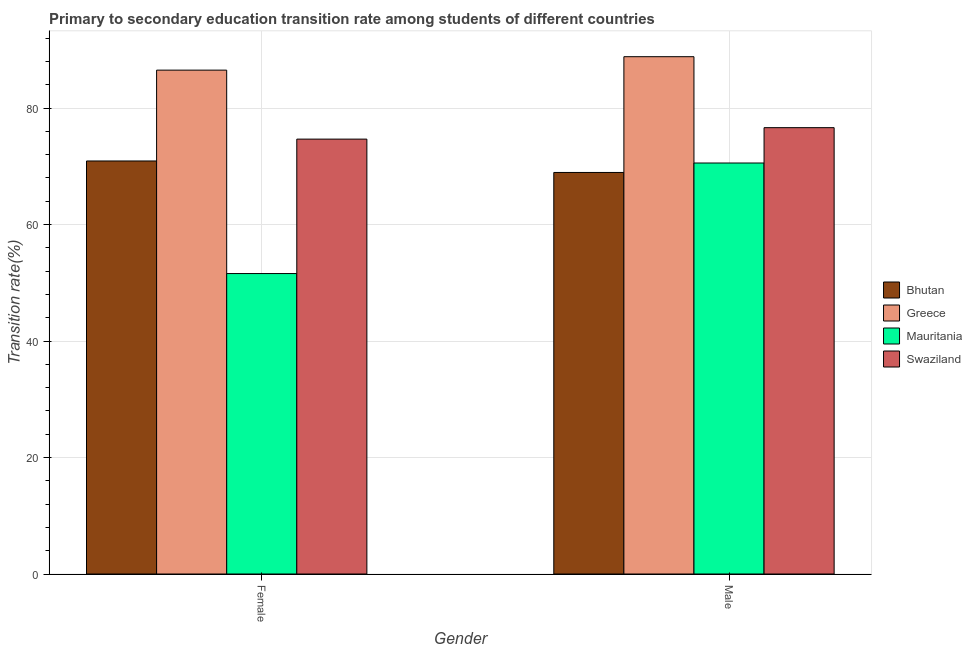How many different coloured bars are there?
Offer a terse response. 4. Are the number of bars per tick equal to the number of legend labels?
Your answer should be compact. Yes. How many bars are there on the 2nd tick from the right?
Provide a short and direct response. 4. What is the label of the 2nd group of bars from the left?
Keep it short and to the point. Male. What is the transition rate among female students in Mauritania?
Your response must be concise. 51.59. Across all countries, what is the maximum transition rate among female students?
Ensure brevity in your answer.  86.52. Across all countries, what is the minimum transition rate among male students?
Your answer should be very brief. 68.95. In which country was the transition rate among male students maximum?
Provide a succinct answer. Greece. In which country was the transition rate among female students minimum?
Your answer should be very brief. Mauritania. What is the total transition rate among female students in the graph?
Keep it short and to the point. 283.7. What is the difference between the transition rate among female students in Bhutan and that in Mauritania?
Keep it short and to the point. 19.33. What is the difference between the transition rate among male students in Greece and the transition rate among female students in Mauritania?
Provide a short and direct response. 37.24. What is the average transition rate among male students per country?
Your answer should be compact. 76.25. What is the difference between the transition rate among male students and transition rate among female students in Mauritania?
Your response must be concise. 18.98. In how many countries, is the transition rate among female students greater than 20 %?
Provide a short and direct response. 4. What is the ratio of the transition rate among male students in Bhutan to that in Mauritania?
Provide a succinct answer. 0.98. Is the transition rate among male students in Mauritania less than that in Swaziland?
Provide a succinct answer. Yes. What does the 1st bar from the left in Female represents?
Provide a short and direct response. Bhutan. What does the 2nd bar from the right in Male represents?
Make the answer very short. Mauritania. How many countries are there in the graph?
Offer a very short reply. 4. Where does the legend appear in the graph?
Ensure brevity in your answer.  Center right. How many legend labels are there?
Give a very brief answer. 4. What is the title of the graph?
Make the answer very short. Primary to secondary education transition rate among students of different countries. What is the label or title of the Y-axis?
Your answer should be very brief. Transition rate(%). What is the Transition rate(%) in Bhutan in Female?
Keep it short and to the point. 70.92. What is the Transition rate(%) in Greece in Female?
Ensure brevity in your answer.  86.52. What is the Transition rate(%) of Mauritania in Female?
Provide a succinct answer. 51.59. What is the Transition rate(%) of Swaziland in Female?
Make the answer very short. 74.67. What is the Transition rate(%) of Bhutan in Male?
Your answer should be compact. 68.95. What is the Transition rate(%) of Greece in Male?
Offer a very short reply. 88.83. What is the Transition rate(%) of Mauritania in Male?
Make the answer very short. 70.57. What is the Transition rate(%) in Swaziland in Male?
Provide a succinct answer. 76.64. Across all Gender, what is the maximum Transition rate(%) in Bhutan?
Provide a short and direct response. 70.92. Across all Gender, what is the maximum Transition rate(%) in Greece?
Ensure brevity in your answer.  88.83. Across all Gender, what is the maximum Transition rate(%) of Mauritania?
Offer a terse response. 70.57. Across all Gender, what is the maximum Transition rate(%) in Swaziland?
Provide a succinct answer. 76.64. Across all Gender, what is the minimum Transition rate(%) in Bhutan?
Offer a very short reply. 68.95. Across all Gender, what is the minimum Transition rate(%) in Greece?
Your response must be concise. 86.52. Across all Gender, what is the minimum Transition rate(%) of Mauritania?
Your answer should be very brief. 51.59. Across all Gender, what is the minimum Transition rate(%) of Swaziland?
Provide a short and direct response. 74.67. What is the total Transition rate(%) in Bhutan in the graph?
Keep it short and to the point. 139.87. What is the total Transition rate(%) in Greece in the graph?
Keep it short and to the point. 175.34. What is the total Transition rate(%) in Mauritania in the graph?
Offer a terse response. 122.16. What is the total Transition rate(%) of Swaziland in the graph?
Make the answer very short. 151.31. What is the difference between the Transition rate(%) in Bhutan in Female and that in Male?
Your response must be concise. 1.97. What is the difference between the Transition rate(%) in Greece in Female and that in Male?
Offer a very short reply. -2.31. What is the difference between the Transition rate(%) of Mauritania in Female and that in Male?
Your answer should be compact. -18.98. What is the difference between the Transition rate(%) of Swaziland in Female and that in Male?
Provide a short and direct response. -1.97. What is the difference between the Transition rate(%) in Bhutan in Female and the Transition rate(%) in Greece in Male?
Provide a succinct answer. -17.91. What is the difference between the Transition rate(%) in Bhutan in Female and the Transition rate(%) in Mauritania in Male?
Make the answer very short. 0.35. What is the difference between the Transition rate(%) of Bhutan in Female and the Transition rate(%) of Swaziland in Male?
Ensure brevity in your answer.  -5.72. What is the difference between the Transition rate(%) of Greece in Female and the Transition rate(%) of Mauritania in Male?
Ensure brevity in your answer.  15.95. What is the difference between the Transition rate(%) in Greece in Female and the Transition rate(%) in Swaziland in Male?
Make the answer very short. 9.88. What is the difference between the Transition rate(%) in Mauritania in Female and the Transition rate(%) in Swaziland in Male?
Give a very brief answer. -25.05. What is the average Transition rate(%) in Bhutan per Gender?
Keep it short and to the point. 69.93. What is the average Transition rate(%) in Greece per Gender?
Make the answer very short. 87.67. What is the average Transition rate(%) in Mauritania per Gender?
Your answer should be very brief. 61.08. What is the average Transition rate(%) in Swaziland per Gender?
Keep it short and to the point. 75.66. What is the difference between the Transition rate(%) of Bhutan and Transition rate(%) of Greece in Female?
Your answer should be compact. -15.6. What is the difference between the Transition rate(%) of Bhutan and Transition rate(%) of Mauritania in Female?
Offer a terse response. 19.33. What is the difference between the Transition rate(%) of Bhutan and Transition rate(%) of Swaziland in Female?
Make the answer very short. -3.75. What is the difference between the Transition rate(%) in Greece and Transition rate(%) in Mauritania in Female?
Your answer should be compact. 34.93. What is the difference between the Transition rate(%) of Greece and Transition rate(%) of Swaziland in Female?
Offer a very short reply. 11.85. What is the difference between the Transition rate(%) in Mauritania and Transition rate(%) in Swaziland in Female?
Your answer should be very brief. -23.08. What is the difference between the Transition rate(%) in Bhutan and Transition rate(%) in Greece in Male?
Give a very brief answer. -19.88. What is the difference between the Transition rate(%) of Bhutan and Transition rate(%) of Mauritania in Male?
Provide a succinct answer. -1.62. What is the difference between the Transition rate(%) in Bhutan and Transition rate(%) in Swaziland in Male?
Keep it short and to the point. -7.69. What is the difference between the Transition rate(%) of Greece and Transition rate(%) of Mauritania in Male?
Give a very brief answer. 18.26. What is the difference between the Transition rate(%) of Greece and Transition rate(%) of Swaziland in Male?
Provide a short and direct response. 12.19. What is the difference between the Transition rate(%) in Mauritania and Transition rate(%) in Swaziland in Male?
Offer a very short reply. -6.07. What is the ratio of the Transition rate(%) of Bhutan in Female to that in Male?
Your response must be concise. 1.03. What is the ratio of the Transition rate(%) of Mauritania in Female to that in Male?
Provide a short and direct response. 0.73. What is the ratio of the Transition rate(%) of Swaziland in Female to that in Male?
Your response must be concise. 0.97. What is the difference between the highest and the second highest Transition rate(%) of Bhutan?
Give a very brief answer. 1.97. What is the difference between the highest and the second highest Transition rate(%) in Greece?
Provide a succinct answer. 2.31. What is the difference between the highest and the second highest Transition rate(%) of Mauritania?
Your answer should be very brief. 18.98. What is the difference between the highest and the second highest Transition rate(%) in Swaziland?
Give a very brief answer. 1.97. What is the difference between the highest and the lowest Transition rate(%) of Bhutan?
Ensure brevity in your answer.  1.97. What is the difference between the highest and the lowest Transition rate(%) of Greece?
Provide a short and direct response. 2.31. What is the difference between the highest and the lowest Transition rate(%) of Mauritania?
Ensure brevity in your answer.  18.98. What is the difference between the highest and the lowest Transition rate(%) of Swaziland?
Give a very brief answer. 1.97. 